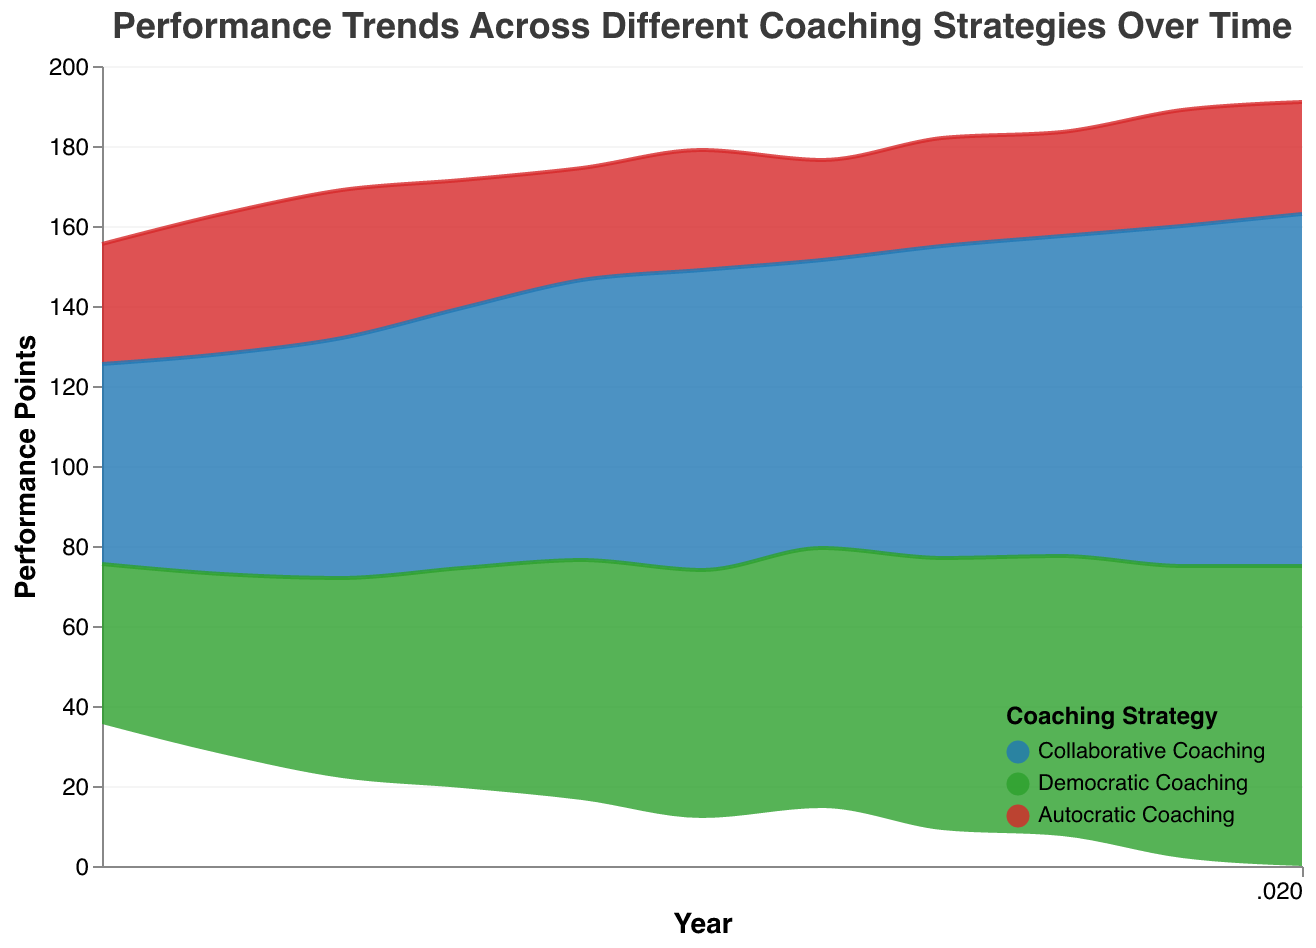What is the title of the figure? The title is usually located at the top of the figure. It explains what the figure represents, which in this case should be "Performance Trends Across Different Coaching Strategies Over Time" as mentioned in the code.
Answer: Performance Trends Across Different Coaching Strategies Over Time Which coaching strategy had the highest performance points in 2020? We need to look at the end of the timeline and check the values for each coaching strategy in 2020. The figure shows that "Collaborative Coaching" had the highest with 88 points.
Answer: Collaborative Coaching How has the performance of Autocratic Coaching changed from 2010 to 2020? To determine this, we compare the values at the beginning and end of the given timeframe. In 2010, it was 30 points, and in 2020, it was 28 points. Therefore, it has slightly decreased.
Answer: Decreased What is the overall trend for Democratic Coaching from 2010 to 2020? Observing the trendline for Democratic Coaching, we see that its performance points generally increase from 40 in 2010 to 75 in 2020.
Answer: Increasing Which year did Collaborative Coaching first reach a performance point of 70 or more? We look for the first instance where the Collaborative Coaching strategy reaches or exceeds 70 points. According to the figure, this happens in 2014.
Answer: 2014 Between which two consecutive years did Democratic Coaching see the largest increase in performance points? To find the largest increase, we calculate the differences between consecutive years for Democratic Coaching. The largest increase occurs between 2010 (40 points) and 2011 (45 points), which is 5 points.
Answer: 2010 and 2011 Compare the performance trend of Collaborative Coaching and Autocratic Coaching from 2010 to 2020. Collaborative Coaching shows a consistent increase from 50 to 88 points, while Autocratic Coaching shows a generally decreasing trend from 30 to 28 points.
Answer: Collaborative Coaching increases, Autocratic Coaching decreases How many different coaching strategies are represented in the figure? By examining the color legend, we can see that there are three distinct categories: Collaborative Coaching, Autocratic Coaching, and Democratic Coaching.
Answer: Three What can be inferred about the dominance of coaching strategies over time? By looking at the stacked area graph, it's evident that Collaborative Coaching consistently occupies a larger area in the stream graph compared to the other strategies, indicating its dominant and increasing effectiveness over time.
Answer: Collaborative Coaching dominates If we average the performance points for all coaching strategies in 2015, what value do we get? The performance points for 2015 are Collaborative Coaching (75), Autocratic Coaching (30), and Democratic Coaching (62). The average is (75 + 30 + 62) / 3 = 55.67.
Answer: 55.67 